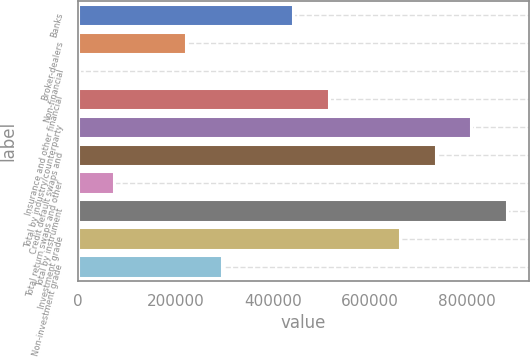<chart> <loc_0><loc_0><loc_500><loc_500><bar_chart><fcel>Banks<fcel>Broker-dealers<fcel>Non-financial<fcel>Insurance and other financial<fcel>Total by industry/counterparty<fcel>Credit default swaps and<fcel>Total return swaps and other<fcel>Total by instrument<fcel>Investment grade<fcel>Non-investment grade<nl><fcel>441541<fcel>221341<fcel>1140<fcel>514941<fcel>808542<fcel>735142<fcel>74540.2<fcel>881942<fcel>661742<fcel>294741<nl></chart> 